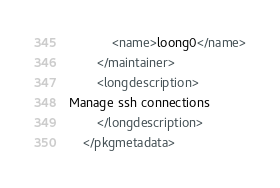Convert code to text. <code><loc_0><loc_0><loc_500><loc_500><_XML_>			<name>loong0</name>
		</maintainer>
		<longdescription>
Manage ssh connections
		</longdescription>
	</pkgmetadata>
</code> 